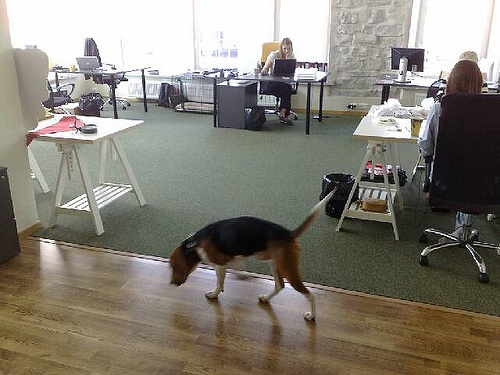Describe the objects in this image and their specific colors. I can see chair in tan, black, gray, darkgray, and lightgray tones, dog in tan, black, gray, and maroon tones, people in tan, gray, maroon, black, and darkgray tones, people in tan, black, gray, darkgray, and lightgray tones, and chair in tan, gray, darkgray, white, and black tones in this image. 